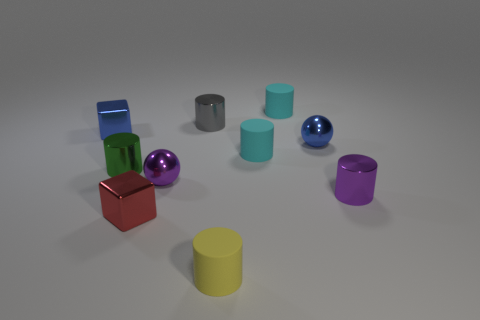Are the materials of these objects the same? No, the objects appear to be made of different materials. Some have a metallic luster, like the purple ball and the silver cylinder, suggesting they might be metal, while others have a matte finish, which might indicate plastic or painted surfaces. 